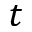<formula> <loc_0><loc_0><loc_500><loc_500>t</formula> 